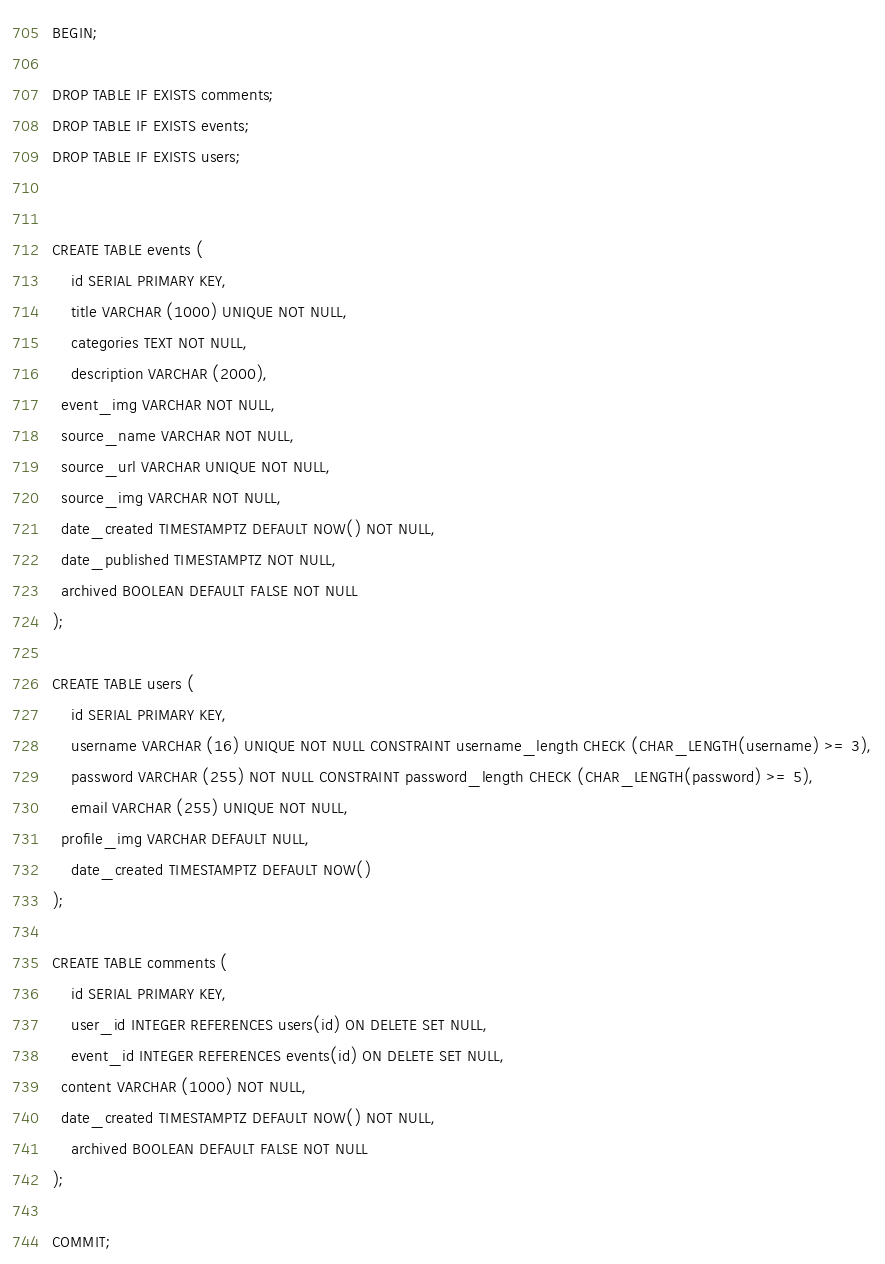<code> <loc_0><loc_0><loc_500><loc_500><_SQL_>BEGIN;

DROP TABLE IF EXISTS comments;
DROP TABLE IF EXISTS events;
DROP TABLE IF EXISTS users;


CREATE TABLE events (
	id SERIAL PRIMARY KEY,
	title VARCHAR (1000) UNIQUE NOT NULL,
	categories TEXT NOT NULL,
	description VARCHAR (2000),
  event_img VARCHAR NOT NULL,
  source_name VARCHAR NOT NULL,
  source_url VARCHAR UNIQUE NOT NULL,
  source_img VARCHAR NOT NULL,
  date_created TIMESTAMPTZ DEFAULT NOW() NOT NULL,
  date_published TIMESTAMPTZ NOT NULL,
  archived BOOLEAN DEFAULT FALSE NOT NULL
);

CREATE TABLE users (
	id SERIAL PRIMARY KEY,
	username VARCHAR (16) UNIQUE NOT NULL CONSTRAINT username_length CHECK (CHAR_LENGTH(username) >= 3),
	password VARCHAR (255) NOT NULL CONSTRAINT password_length CHECK (CHAR_LENGTH(password) >= 5),
	email VARCHAR (255) UNIQUE NOT NULL,
  profile_img VARCHAR DEFAULT NULL,
	date_created TIMESTAMPTZ DEFAULT NOW()
);

CREATE TABLE comments (
	id SERIAL PRIMARY KEY,
	user_id INTEGER REFERENCES users(id) ON DELETE SET NULL,
	event_id INTEGER REFERENCES events(id) ON DELETE SET NULL,
  content VARCHAR (1000) NOT NULL,
  date_created TIMESTAMPTZ DEFAULT NOW() NOT NULL,
	archived BOOLEAN DEFAULT FALSE NOT NULL
);

COMMIT;
</code> 